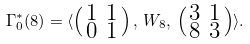<formula> <loc_0><loc_0><loc_500><loc_500>\Gamma _ { 0 } ^ { * } ( 8 ) = \langle \left ( \begin{smallmatrix} 1 & 1 \\ 0 & 1 \end{smallmatrix} \right ) , \, W _ { 8 } , \, \left ( \begin{smallmatrix} 3 & 1 \\ 8 & 3 \end{smallmatrix} \right ) \rangle .</formula> 